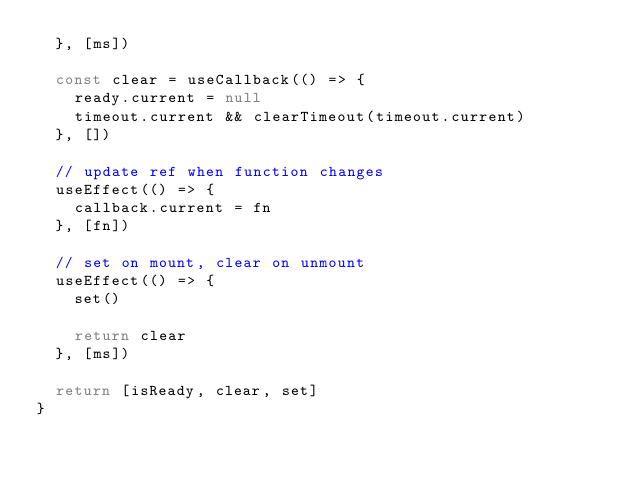Convert code to text. <code><loc_0><loc_0><loc_500><loc_500><_JavaScript_>  }, [ms])

  const clear = useCallback(() => {
    ready.current = null
    timeout.current && clearTimeout(timeout.current)
  }, [])

  // update ref when function changes
  useEffect(() => {
    callback.current = fn
  }, [fn])

  // set on mount, clear on unmount
  useEffect(() => {
    set()

    return clear
  }, [ms])

  return [isReady, clear, set]
}
</code> 